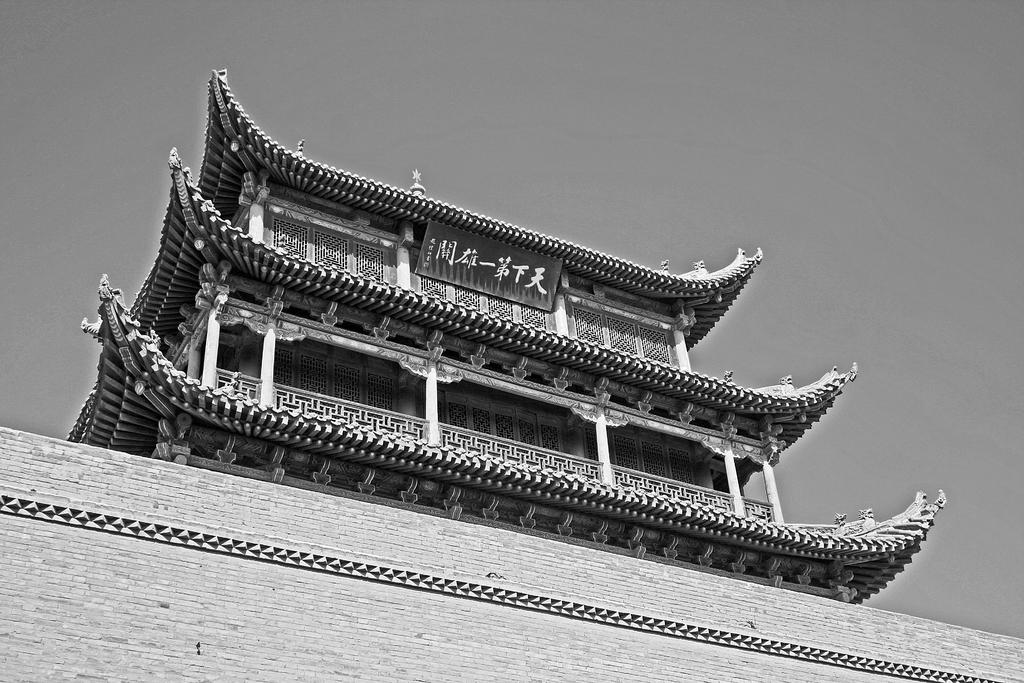What structure can be seen in the picture? There is a building in the picture. What is attached to the top of the building? There is a banner at the top of the building. What is visible at the top of the picture? The sky is visible at the top of the picture. What can be seen in the sky? Clouds are present in the sky. What type of material is used for the wall at the bottom of the picture? There is a brick wall at the bottom of the picture. What type of grass is growing on the roof of the building in the image? There is no grass visible on the roof of the building in the image. What flavor of butter can be seen melting on the banner in the image? There is no butter present in the image. 